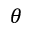Convert formula to latex. <formula><loc_0><loc_0><loc_500><loc_500>\theta</formula> 